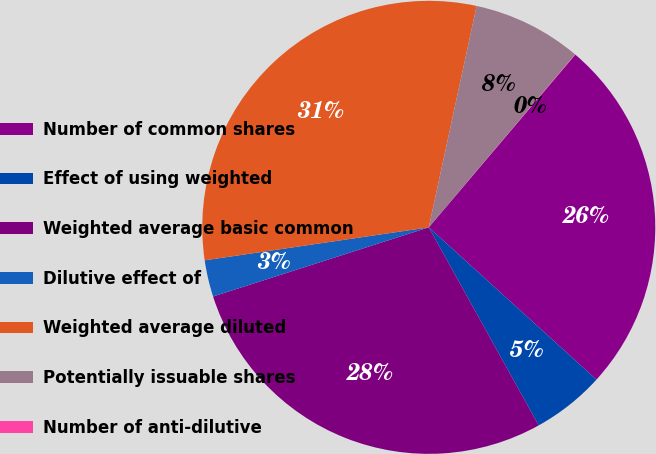<chart> <loc_0><loc_0><loc_500><loc_500><pie_chart><fcel>Number of common shares<fcel>Effect of using weighted<fcel>Weighted average basic common<fcel>Dilutive effect of<fcel>Weighted average diluted<fcel>Potentially issuable shares<fcel>Number of anti-dilutive<nl><fcel>25.54%<fcel>5.2%<fcel>28.13%<fcel>2.61%<fcel>30.72%<fcel>7.79%<fcel>0.02%<nl></chart> 